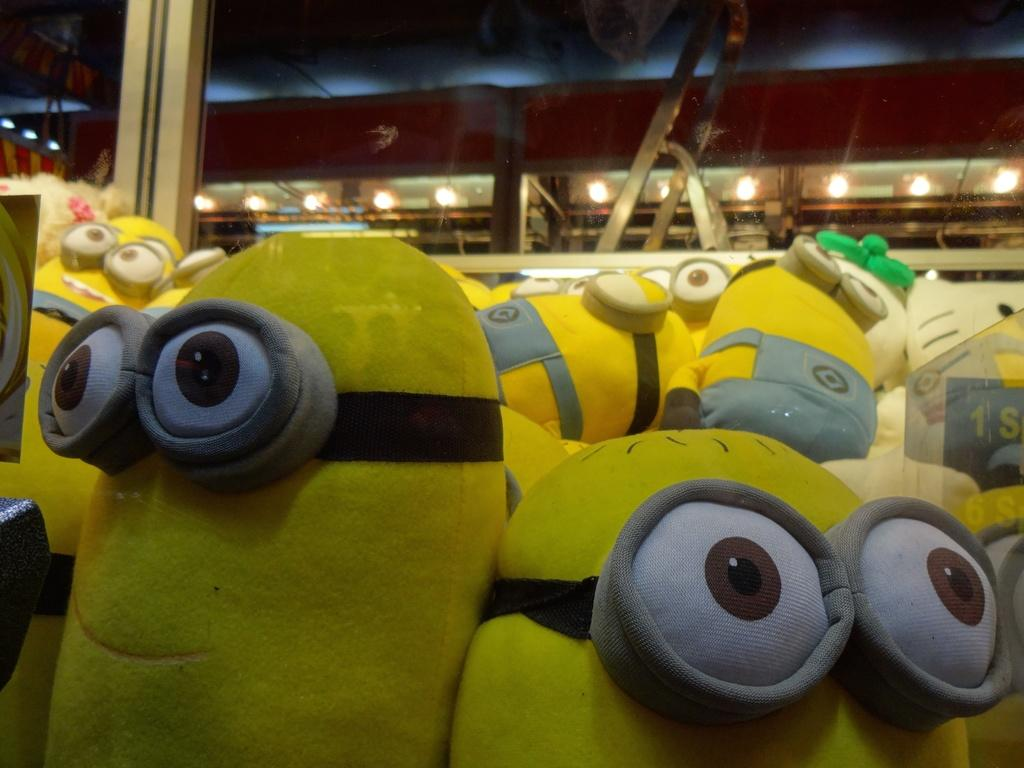What type of objects are in the image? There are soft toys in the image. Where are the soft toys located in relation to the scene? The soft toys are in front of the scene. What can be seen in the background of the image? There are lights visible in the background of the image. What type of reward is being given to the soft toys in the image? There is no reward being given to the soft toys in the image; they are simply placed in front of the scene. 